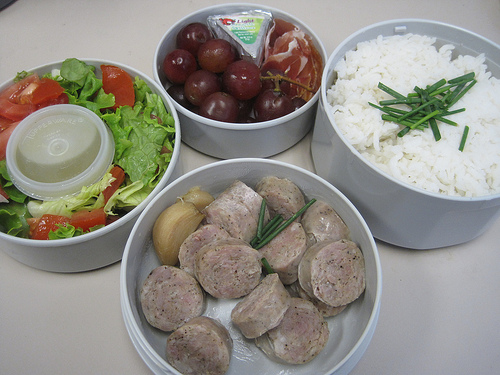<image>
Is the plums above the meat? No. The plums is not positioned above the meat. The vertical arrangement shows a different relationship. Where is the grapes in relation to the salad? Is it above the salad? No. The grapes is not positioned above the salad. The vertical arrangement shows a different relationship. 